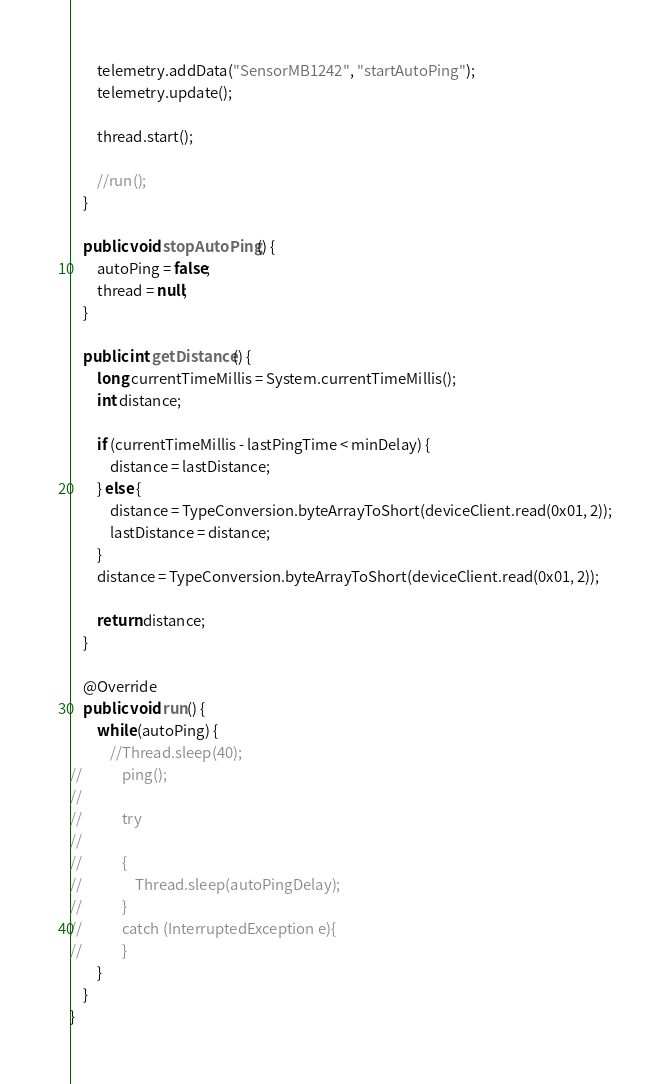Convert code to text. <code><loc_0><loc_0><loc_500><loc_500><_Java_>        telemetry.addData("SensorMB1242", "startAutoPing");
        telemetry.update();

        thread.start();

        //run();
    }

    public void stopAutoPing() {
        autoPing = false;
        thread = null;
    }

    public int getDistance() {
        long currentTimeMillis = System.currentTimeMillis();
        int distance;

        if (currentTimeMillis - lastPingTime < minDelay) {
            distance = lastDistance;
        } else {
            distance = TypeConversion.byteArrayToShort(deviceClient.read(0x01, 2));
            lastDistance = distance;
        }
        distance = TypeConversion.byteArrayToShort(deviceClient.read(0x01, 2));

        return distance;
    }

    @Override
    public void run() {
        while (autoPing) {
            //Thread.sleep(40);
//            ping();
//
//            try
//
//            {
//                Thread.sleep(autoPingDelay);
//            }
//            catch (InterruptedException e){
//            }
        }
    }
}
</code> 